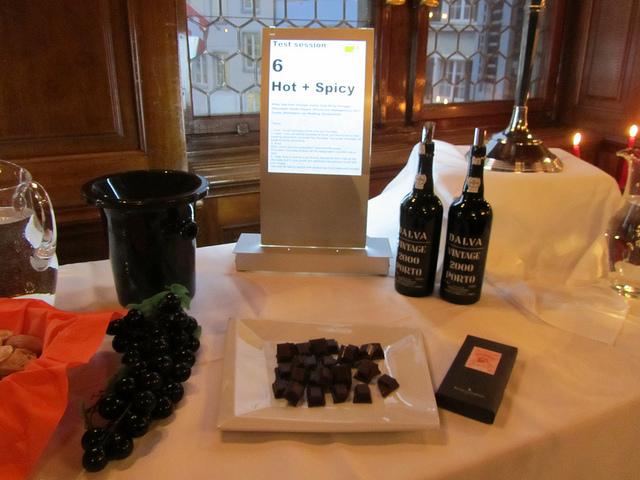Is it an indoor scene?
Quick response, please. Yes. What is on the white plate?
Concise answer only. Chocolate. What does the screen say?
Concise answer only. Hot + spicy. 